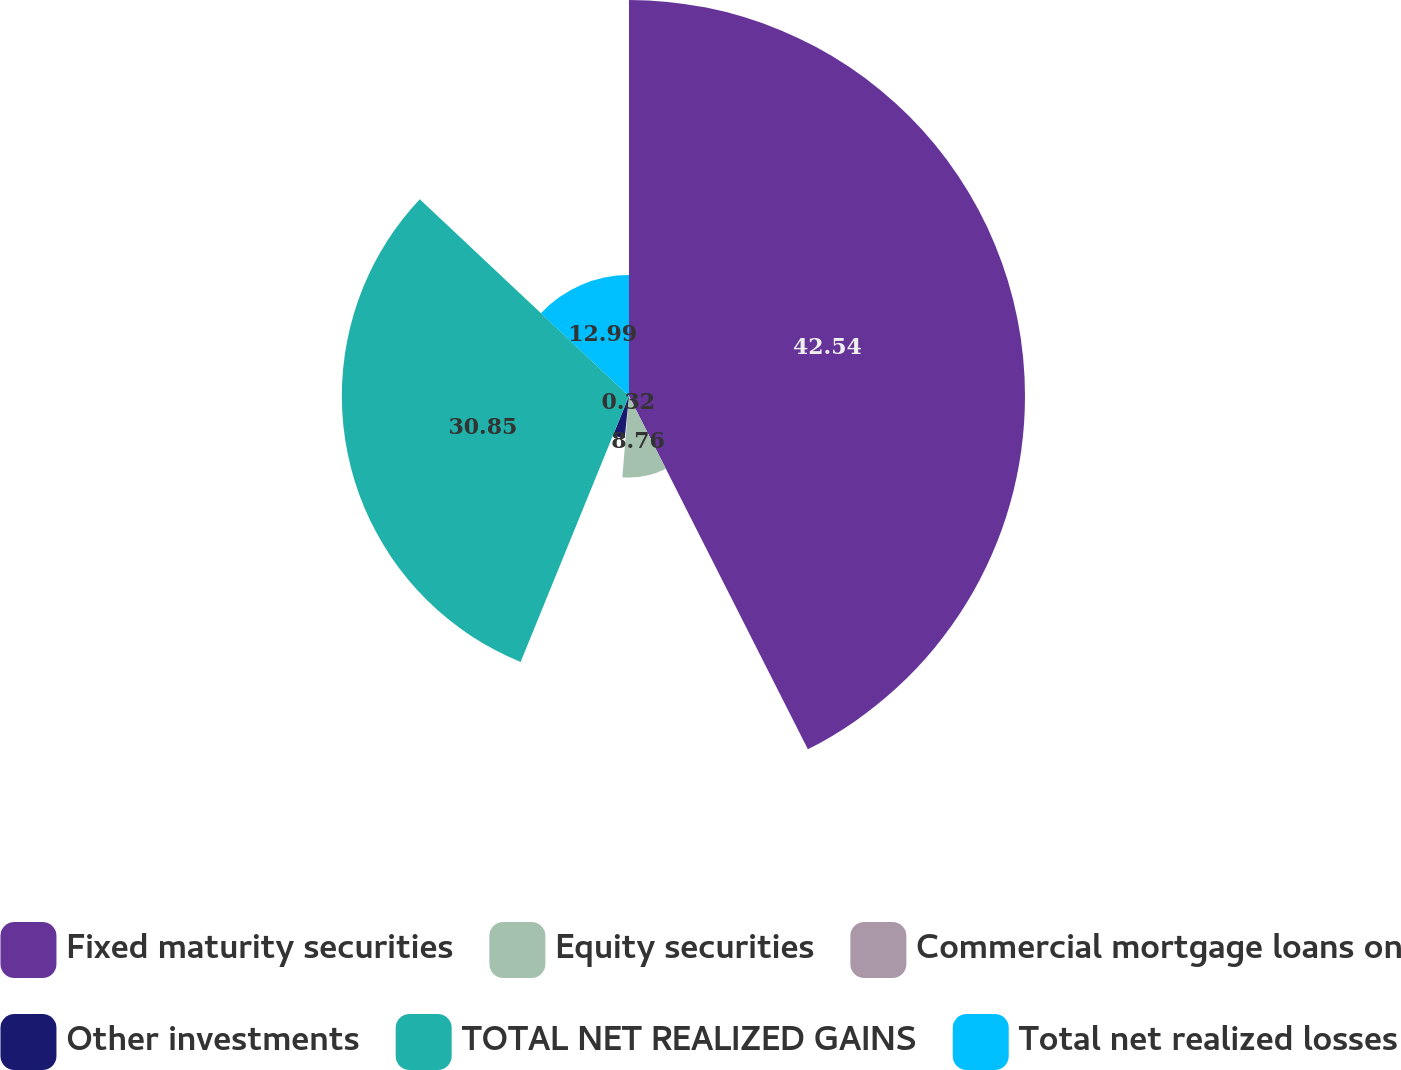Convert chart to OTSL. <chart><loc_0><loc_0><loc_500><loc_500><pie_chart><fcel>Fixed maturity securities<fcel>Equity securities<fcel>Commercial mortgage loans on<fcel>Other investments<fcel>TOTAL NET REALIZED GAINS<fcel>Total net realized losses<nl><fcel>42.54%<fcel>8.76%<fcel>0.32%<fcel>4.54%<fcel>30.85%<fcel>12.99%<nl></chart> 